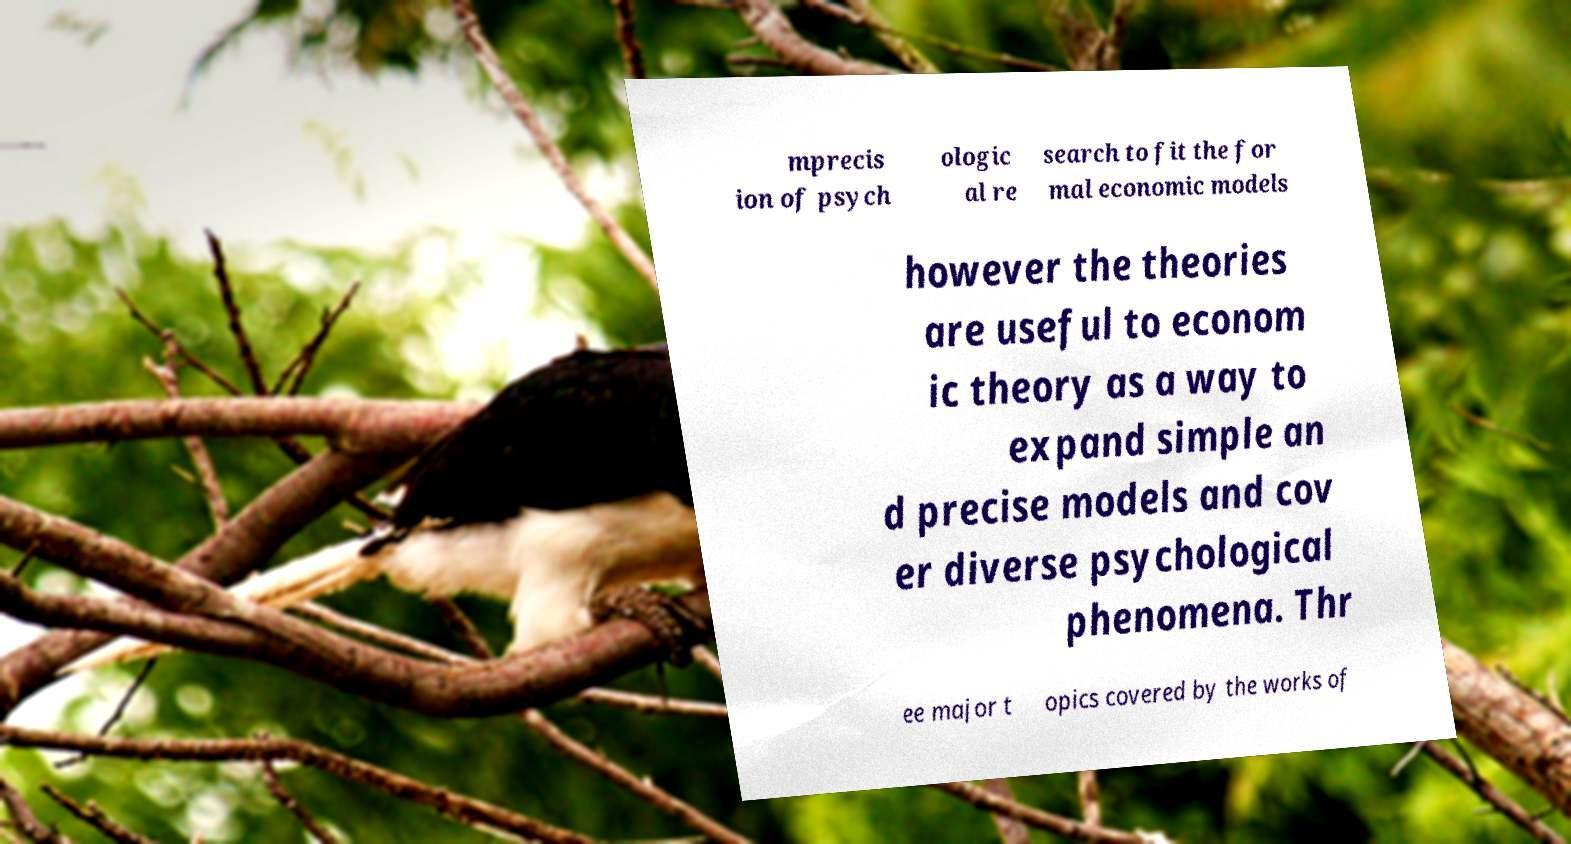For documentation purposes, I need the text within this image transcribed. Could you provide that? mprecis ion of psych ologic al re search to fit the for mal economic models however the theories are useful to econom ic theory as a way to expand simple an d precise models and cov er diverse psychological phenomena. Thr ee major t opics covered by the works of 